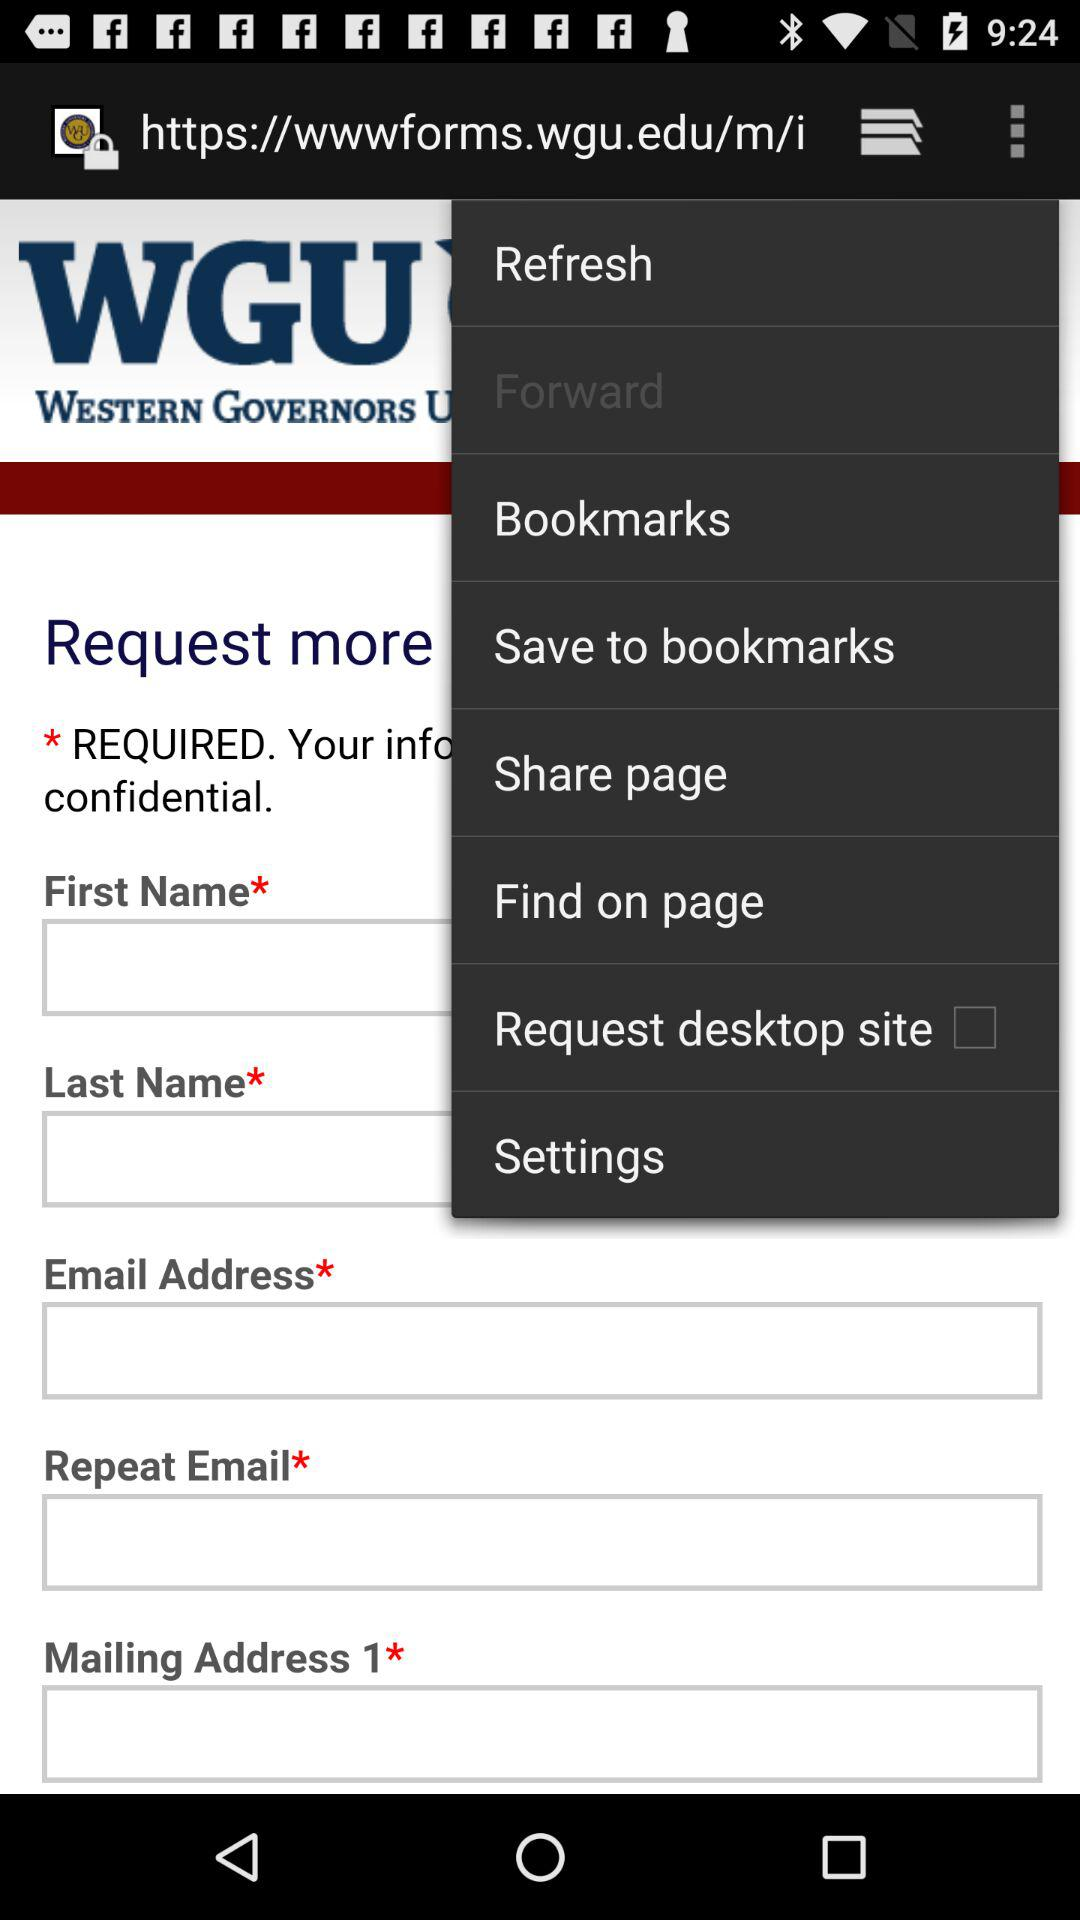What is the status of the "Request desktop site" setting? The status is "off". 